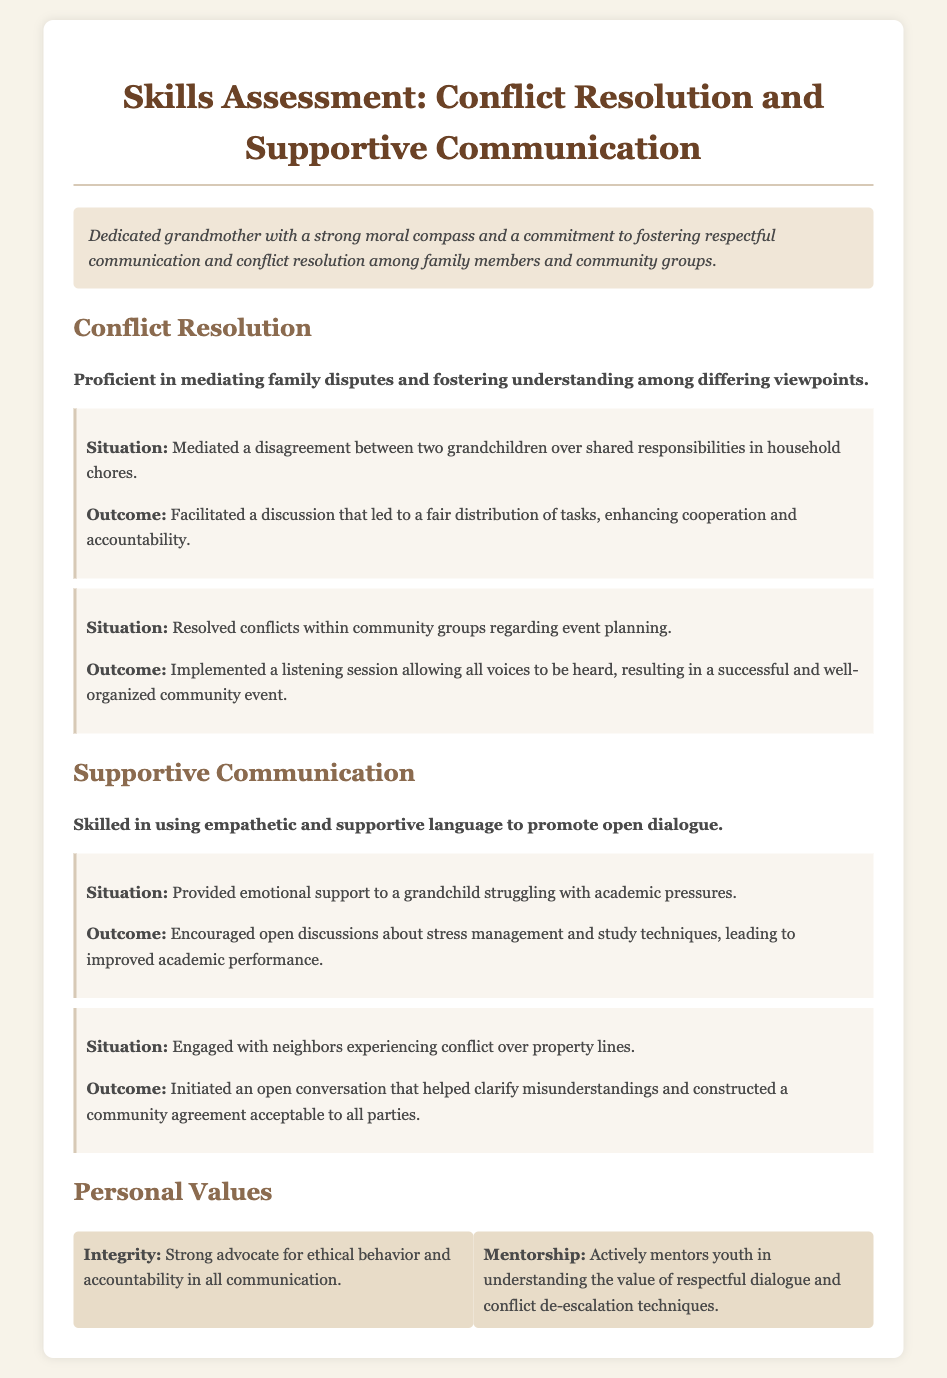What is the title of the document? The title of the document is prominently displayed at the top of the resume.
Answer: Skills Assessment: Conflict Resolution and Supportive Communication What personal value emphasizes ethical behavior? The document lists several personal values, one of which specifically highlights ethics.
Answer: Integrity What situation involved grandchildren and household chores? One of the conflict resolution examples mentions a specific situation with grandchildren regarding chores.
Answer: Mediated a disagreement between two grandchildren over shared responsibilities in household chores What was the outcome of the emotional support provided to a grandchild? The document describes the result of supportive communication in relation to a grandchild's academic stress.
Answer: Improved academic performance In which community situation did the grandmother engage with neighbors? The document references a particular situation involving neighbors that showcases supportive communication skills.
Answer: Conflict over property lines How many situations are described under conflict resolution? The section on conflict resolution provides two specific examples of situations handled.
Answer: Two 